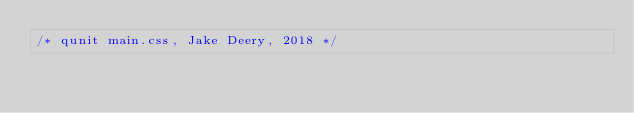<code> <loc_0><loc_0><loc_500><loc_500><_CSS_>/* qunit main.css, Jake Deery, 2018 */
</code> 